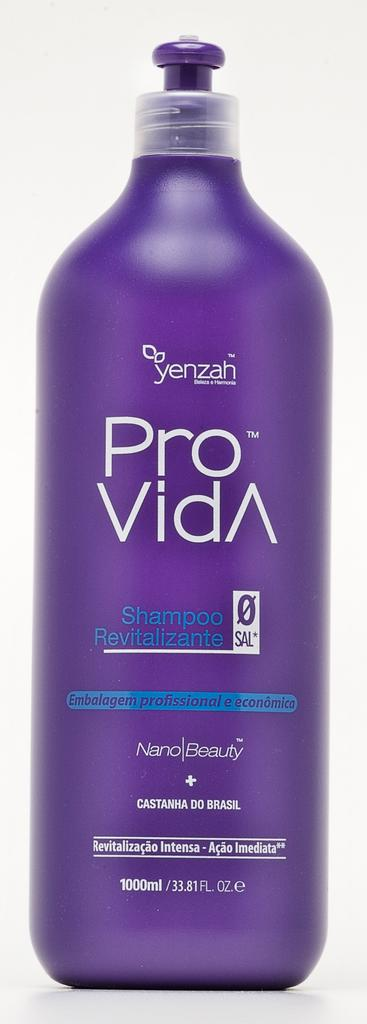<image>
Relay a brief, clear account of the picture shown. Purple bottle of Pro Vida by Yenzah in front of a white background. 